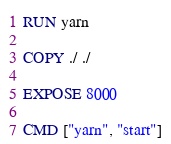Convert code to text. <code><loc_0><loc_0><loc_500><loc_500><_Dockerfile_>RUN yarn

COPY ./ ./

EXPOSE 8000

CMD ["yarn", "start"]



</code> 